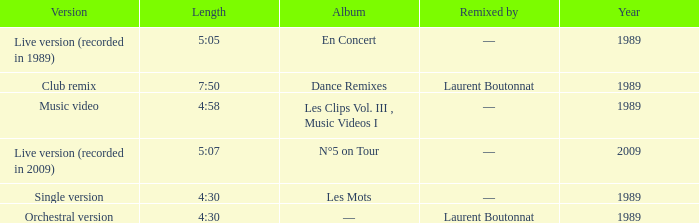Album of les mots had what lowest year? 1989.0. Can you parse all the data within this table? {'header': ['Version', 'Length', 'Album', 'Remixed by', 'Year'], 'rows': [['Live version (recorded in 1989)', '5:05', 'En Concert', '—', '1989'], ['Club remix', '7:50', 'Dance Remixes', 'Laurent Boutonnat', '1989'], ['Music video', '4:58', 'Les Clips Vol. III , Music Videos I', '—', '1989'], ['Live version (recorded in 2009)', '5:07', 'N°5 on Tour', '—', '2009'], ['Single version', '4:30', 'Les Mots', '—', '1989'], ['Orchestral version', '4:30', '—', 'Laurent Boutonnat', '1989']]} 